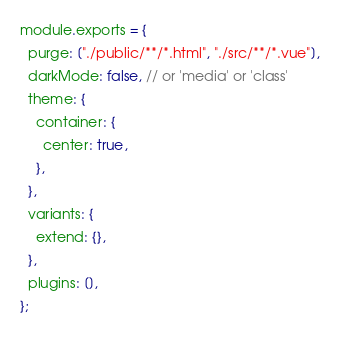<code> <loc_0><loc_0><loc_500><loc_500><_JavaScript_>module.exports = {
  purge: ["./public/**/*.html", "./src/**/*.vue"],
  darkMode: false, // or 'media' or 'class'
  theme: {
    container: {
      center: true,
    },
  },
  variants: {
    extend: {},
  },
  plugins: [],
};
</code> 